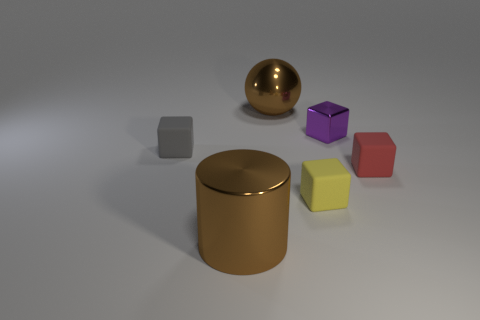Does the rubber cube in front of the tiny red rubber thing have the same size as the rubber object that is on the left side of the brown ball?
Your answer should be compact. Yes. There is a big object that is in front of the tiny cube on the right side of the purple metallic object; what is its shape?
Make the answer very short. Cylinder. Are there an equal number of small purple blocks to the right of the tiny red matte thing and blue shiny balls?
Provide a short and direct response. Yes. There is a brown thing that is in front of the tiny thing behind the rubber object left of the yellow matte block; what is its material?
Ensure brevity in your answer.  Metal. Is there a yellow rubber cylinder that has the same size as the yellow cube?
Provide a short and direct response. No. The tiny red matte object has what shape?
Ensure brevity in your answer.  Cube. What number of blocks are blue rubber objects or brown objects?
Provide a succinct answer. 0. Are there an equal number of big objects right of the yellow thing and large cylinders that are right of the large metallic cylinder?
Provide a succinct answer. Yes. There is a big metal object that is to the left of the brown thing behind the small red matte object; what number of large metal spheres are in front of it?
Provide a succinct answer. 0. What shape is the metallic thing that is the same color as the metal ball?
Give a very brief answer. Cylinder. 